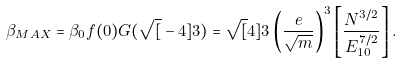Convert formula to latex. <formula><loc_0><loc_0><loc_500><loc_500>\beta _ { M A X } = \beta _ { 0 } f ( 0 ) G ( \sqrt { [ } - 4 ] { 3 } ) = \sqrt { [ } 4 ] { 3 } \left ( \frac { e } { \sqrt { m } } \right ) ^ { 3 } \left [ \frac { N ^ { 3 / 2 } } { E _ { 1 0 } ^ { 7 / 2 } } \right ] .</formula> 